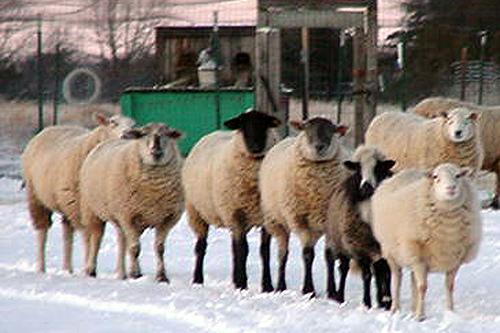How many sheep are there?
Give a very brief answer. 8. How many sheep is this?
Give a very brief answer. 8. 